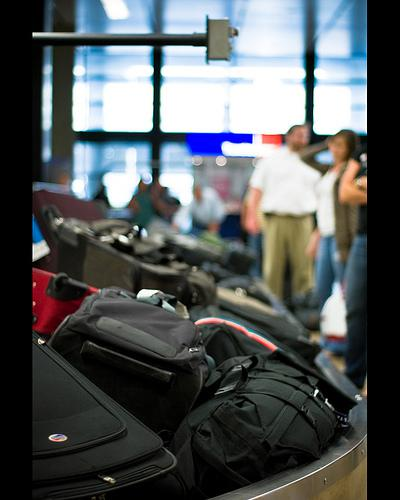Question: where is this taken?
Choices:
A. Subway.
B. An airport.
C. Train station.
D. Driveway.
Answer with the letter. Answer: B Question: what color are most of the bags?
Choices:
A. White.
B. Brown.
C. Tan.
D. Black.
Answer with the letter. Answer: D Question: why are the people standing?
Choices:
A. The people are waiting for their luggage.
B. They're waiting for incoming passengers.
C. Looking for a taxi.
D. Watching a car accident aftermath.
Answer with the letter. Answer: A Question: how many red bags are there?
Choices:
A. Two.
B. One.
C. Three.
D. Four.
Answer with the letter. Answer: B Question: what is in the background?
Choices:
A. The bus station.
B. Parking lot.
C. Used car dealership.
D. The airport terminal.
Answer with the letter. Answer: D 